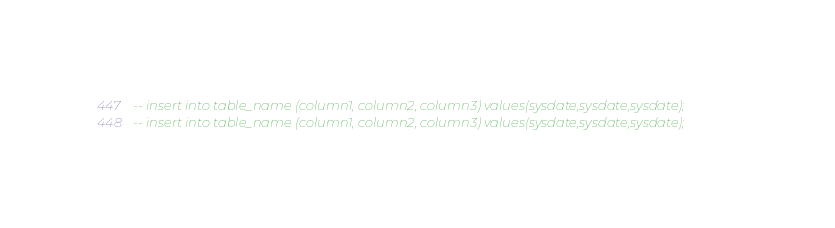Convert code to text. <code><loc_0><loc_0><loc_500><loc_500><_SQL_>-- insert into table_name (column1, column2, column3) values(sysdate,sysdate,sysdate);
-- insert into table_name (column1, column2, column3) values(sysdate,sysdate,sysdate);</code> 